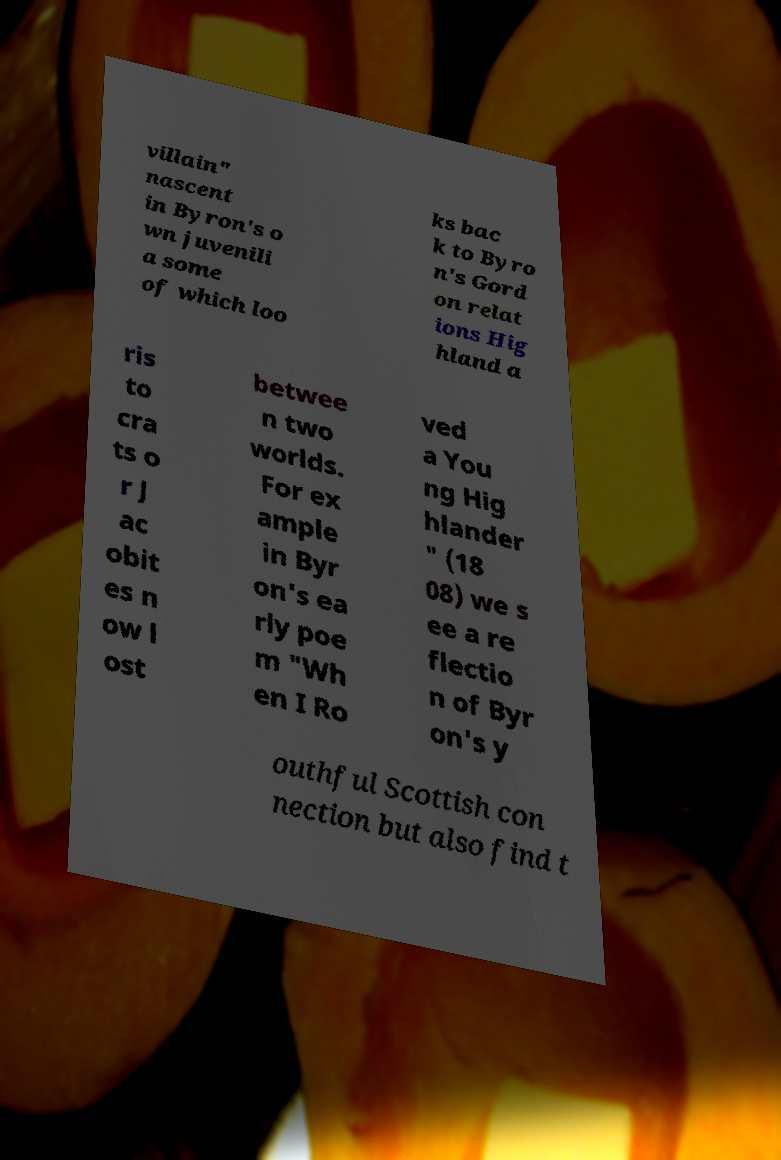Could you assist in decoding the text presented in this image and type it out clearly? villain" nascent in Byron's o wn juvenili a some of which loo ks bac k to Byro n's Gord on relat ions Hig hland a ris to cra ts o r J ac obit es n ow l ost betwee n two worlds. For ex ample in Byr on's ea rly poe m "Wh en I Ro ved a You ng Hig hlander " (18 08) we s ee a re flectio n of Byr on's y outhful Scottish con nection but also find t 